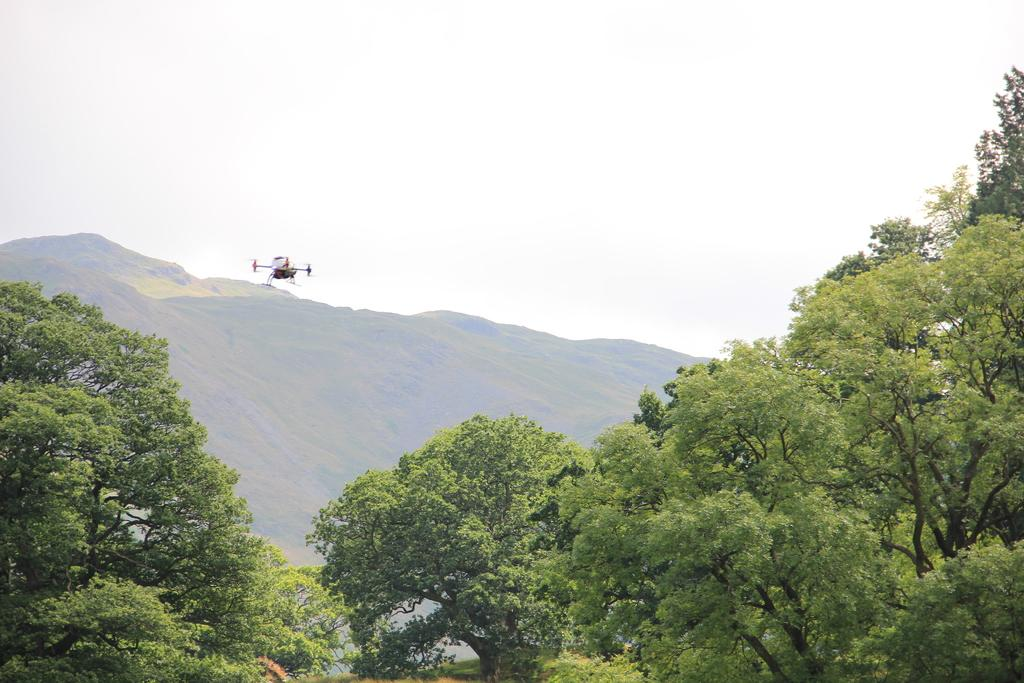What is the main subject of the image? The main subject of the image is an airplane flying. What type of natural features can be seen in the image? There are trees and mountains in the image. What is visible in the background of the image? The sky is visible in the background of the image. Where is the armchair located in the image? There is no armchair present in the image. What type of furniture can be seen in the image? There is no furniture visible in the image; it primarily features an airplane, trees, mountains, and the sky. 